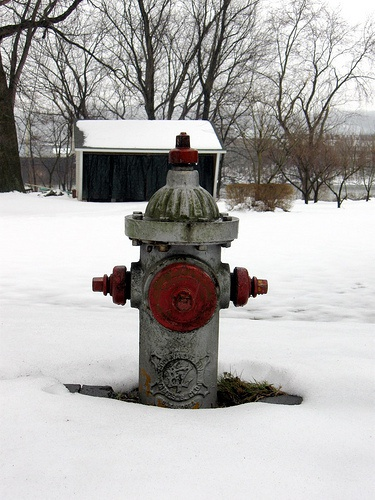Describe the objects in this image and their specific colors. I can see a fire hydrant in gray, black, and maroon tones in this image. 